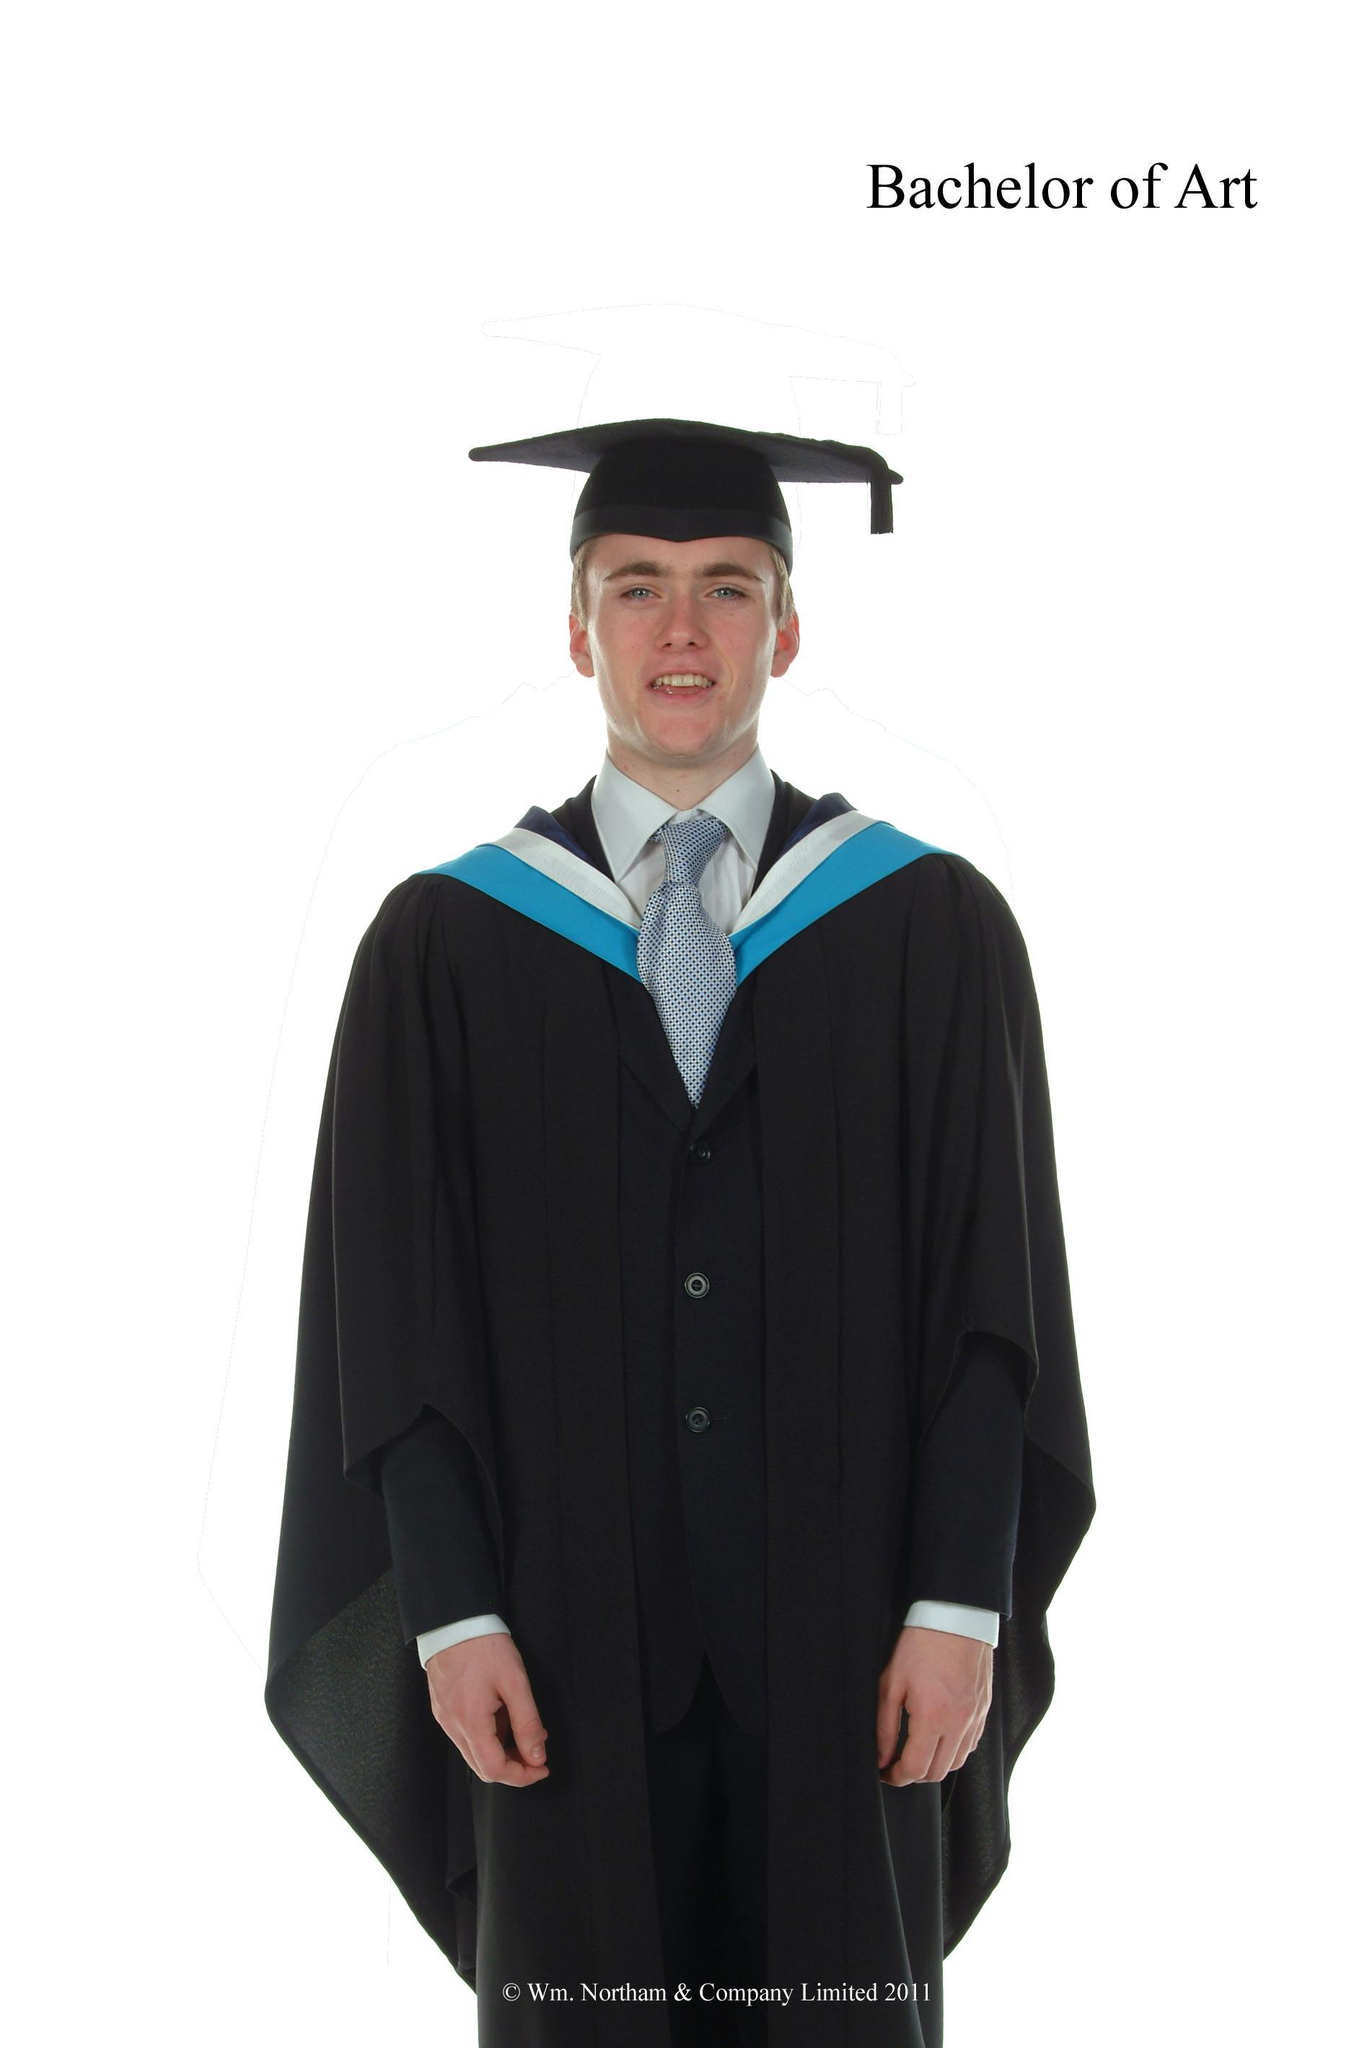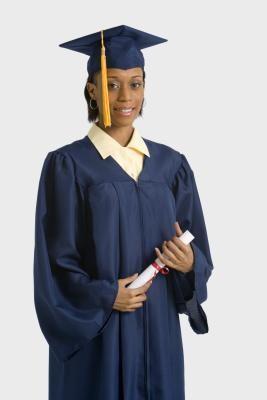The first image is the image on the left, the second image is the image on the right. Assess this claim about the two images: "One of the images features an adult male wearing a black gown and purple color tie.". Correct or not? Answer yes or no. No. The first image is the image on the left, the second image is the image on the right. Assess this claim about the two images: "One of the guys is wearing a purple tie.". Correct or not? Answer yes or no. No. 